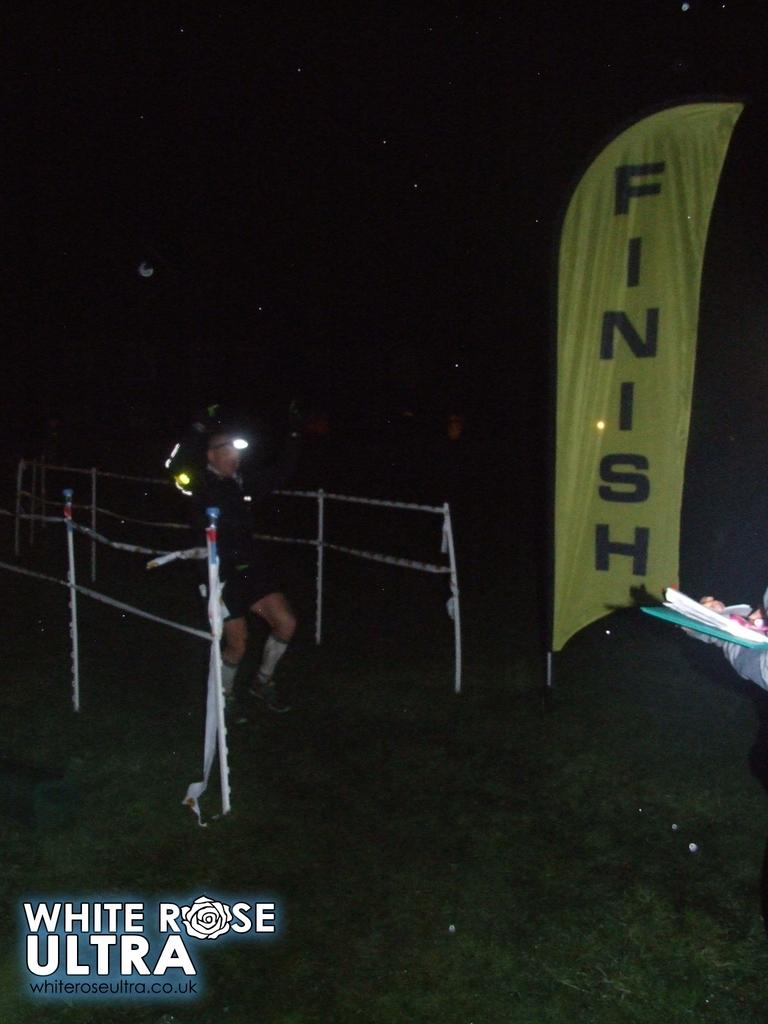What is written on the banner in the image? There is a banner with text in the image, but the specific text is not mentioned in the facts. Can you describe the person in the image? There is a person in the image, but no specific details about their appearance or actions are provided. What is the purpose of the barrier in the image? The purpose of the barrier in the image is not mentioned in the facts. What type of ground surface is visible in the image? There is grass in the image, indicating a natural ground surface. What is the source of light in the image? There is a light in the image, but no details about its type or purpose are provided. What does the text in the bottom left corner of the image say? The text in the bottom left corner of the image is not mentioned in the facts. Is there a baseball game taking place in the image? There is no mention of a baseball game or any related elements in the image. What type of beast can be seen lurking in the background of the image? There is no mention of any beast or creature in the image. 